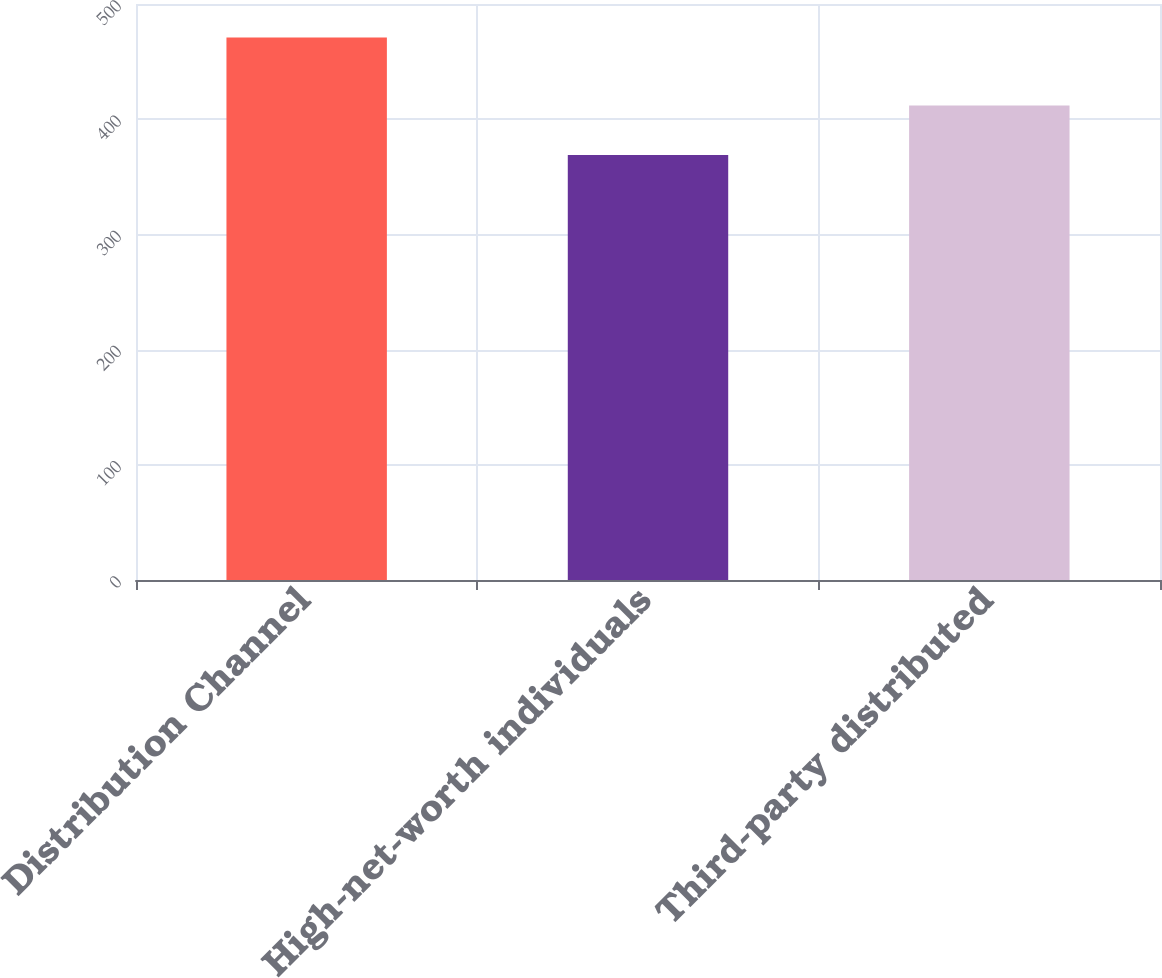Convert chart. <chart><loc_0><loc_0><loc_500><loc_500><bar_chart><fcel>Distribution Channel<fcel>High-net-worth individuals<fcel>Third-party distributed<nl><fcel>471<fcel>369<fcel>412<nl></chart> 